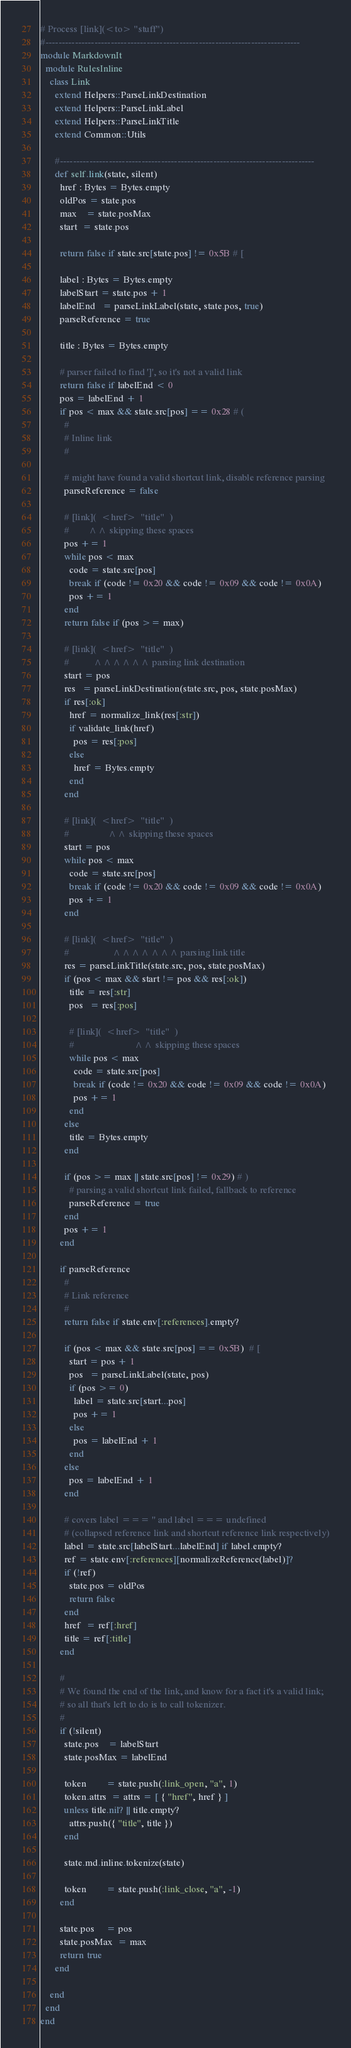<code> <loc_0><loc_0><loc_500><loc_500><_Crystal_># Process [link](<to> "stuff")
#------------------------------------------------------------------------------
module MarkdownIt
  module RulesInline
    class Link
      extend Helpers::ParseLinkDestination
      extend Helpers::ParseLinkLabel
      extend Helpers::ParseLinkTitle
      extend Common::Utils

      #------------------------------------------------------------------------------
      def self.link(state, silent)
        href : Bytes = Bytes.empty
        oldPos = state.pos
        max    = state.posMax
        start  = state.pos

        return false if state.src[state.pos] != 0x5B # [

        label : Bytes = Bytes.empty
        labelStart = state.pos + 1
        labelEnd   = parseLinkLabel(state, state.pos, true)
        parseReference = true

        title : Bytes = Bytes.empty

        # parser failed to find ']', so it's not a valid link
        return false if labelEnd < 0
        pos = labelEnd + 1
        if pos < max && state.src[pos] == 0x28 # (
          #
          # Inline link
          #

          # might have found a valid shortcut link, disable reference parsing
          parseReference = false

          # [link](  <href>  "title"  )
          #        ^^ skipping these spaces
          pos += 1
          while pos < max
            code = state.src[pos]
            break if (code != 0x20 && code != 0x09 && code != 0x0A)
            pos += 1
          end
          return false if (pos >= max)

          # [link](  <href>  "title"  )
          #          ^^^^^^ parsing link destination
          start = pos
          res   = parseLinkDestination(state.src, pos, state.posMax)
          if res[:ok]
            href = normalize_link(res[:str])
            if validate_link(href)
              pos = res[:pos]
            else
              href = Bytes.empty
            end
          end

          # [link](  <href>  "title"  )
          #                ^^ skipping these spaces
          start = pos
          while pos < max
            code = state.src[pos]
            break if (code != 0x20 && code != 0x09 && code != 0x0A)
            pos += 1
          end

          # [link](  <href>  "title"  )
          #                  ^^^^^^^ parsing link title
          res = parseLinkTitle(state.src, pos, state.posMax)
          if (pos < max && start != pos && res[:ok])
            title = res[:str]
            pos   = res[:pos]

            # [link](  <href>  "title"  )
            #                         ^^ skipping these spaces
            while pos < max
              code = state.src[pos]
              break if (code != 0x20 && code != 0x09 && code != 0x0A)
              pos += 1
            end
          else
            title = Bytes.empty
          end

          if (pos >= max || state.src[pos] != 0x29) # )
            # parsing a valid shortcut link failed, fallback to reference
            parseReference = true
          end
          pos += 1
        end

        if parseReference
          #
          # Link reference
          #
          return false if state.env[:references].empty?

          if (pos < max && state.src[pos] == 0x5B)  # [
            start = pos + 1
            pos   = parseLinkLabel(state, pos)
            if (pos >= 0)
              label = state.src[start...pos]
              pos += 1
            else
              pos = labelEnd + 1
            end
          else
            pos = labelEnd + 1
          end

          # covers label === '' and label === undefined
          # (collapsed reference link and shortcut reference link respectively)
          label = state.src[labelStart...labelEnd] if label.empty?
          ref = state.env[:references][normalizeReference(label)]?
          if (!ref)
            state.pos = oldPos
            return false
          end
          href  = ref[:href]
          title = ref[:title]
        end

        #
        # We found the end of the link, and know for a fact it's a valid link;
        # so all that's left to do is to call tokenizer.
        #
        if (!silent)
          state.pos    = labelStart
          state.posMax = labelEnd

          token        = state.push(:link_open, "a", 1)
          token.attrs  = attrs = [ { "href", href } ]
          unless title.nil? || title.empty?
            attrs.push({ "title", title })
          end

          state.md.inline.tokenize(state)

          token        = state.push(:link_close, "a", -1)
        end

        state.pos     = pos
        state.posMax  = max
        return true
      end

    end
  end
end
</code> 